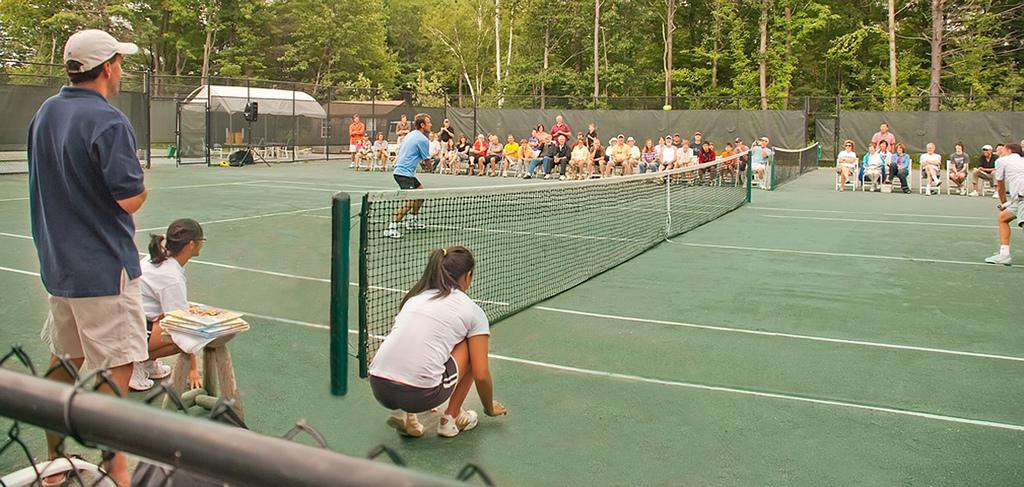Question: where is this picture taken?
Choices:
A. In a park.
B. A tennis court.
C. In a store.
D. At home.
Answer with the letter. Answer: B Question: what sport are they playing?
Choices:
A. Tennis.
B. Soccer.
C. Basketball.
D. Football.
Answer with the letter. Answer: A Question: what is beyond the tennis court?
Choices:
A. Offices.
B. Trees.
C. Homes.
D. Fields.
Answer with the letter. Answer: B Question: what color shirt does the man with the white hat have?
Choices:
A. Red.
B. Black.
C. Grey.
D. Blue.
Answer with the letter. Answer: D Question: what surrounds the tennis court area?
Choices:
A. Chairs.
B. A crowd of people.
C. Trees.
D. The parking lot.
Answer with the letter. Answer: C Question: what does the lady have in her lap?
Choices:
A. Carpet swatches.
B. Children shoes.
C. A bowl of rice.
D. Towels.
Answer with the letter. Answer: D Question: what is the man doing, and what color is his shirt?
Choices:
A. He stands watching, blue.
B. He sits reading, wearing red.
C. He crouches, wearing tan.
D. He squats, wearing black.
Answer with the letter. Answer: A Question: what is the ball girl doing?
Choices:
A. Sits waiting at a tennis match.
B. Running back and forth.
C. Waving her hand.
D. Signaling the ref.
Answer with the letter. Answer: A Question: what is the player on the right wearing?
Choices:
A. White shirt.
B. Blue jeans.
C. Tanktop.
D. A hat.
Answer with the letter. Answer: A Question: what is the player on the left wearing?
Choices:
A. Purple shorts.
B. Yellow shoes.
C. A backpack.
D. Blue shirt.
Answer with the letter. Answer: D Question: what is on a lady's lap?
Choices:
A. A puppy.
B. A sleepy child.
C. A ball of yarn.
D. Stack of papers.
Answer with the letter. Answer: D Question: what kind of day is it?
Choices:
A. Gloomy.
B. Hot.
C. Sunny.
D. Rainy.
Answer with the letter. Answer: C Question: who is crouching by the net?
Choices:
A. The boy.
B. The girl.
C. The man.
D. The women.
Answer with the letter. Answer: B Question: what is one player wearing?
Choices:
A. Red shirt.
B. Baseball cap.
C. A blue shirt.
D. Football jersey.
Answer with the letter. Answer: C Question: how do the spectators sit in this particular match?
Choices:
A. On the grass.
B. In chairs, not stands.
C. In bleachers.
D. In the stands.
Answer with the letter. Answer: B Question: who is getting ready to run for the tennis ball?
Choices:
A. The crouching girl.
B. The ball boy.
C. The golden retriever.
D. The coach.
Answer with the letter. Answer: A Question: what is the ball girl wearing?
Choices:
A. Pink shorts and top.
B. Athletic shoes.
C. A baseball glove.
D. A red hat.
Answer with the letter. Answer: B Question: what is in the foreground?
Choices:
A. Flowers.
B. Birds.
C. Part of a chain link fence.
D. Dog.
Answer with the letter. Answer: C 